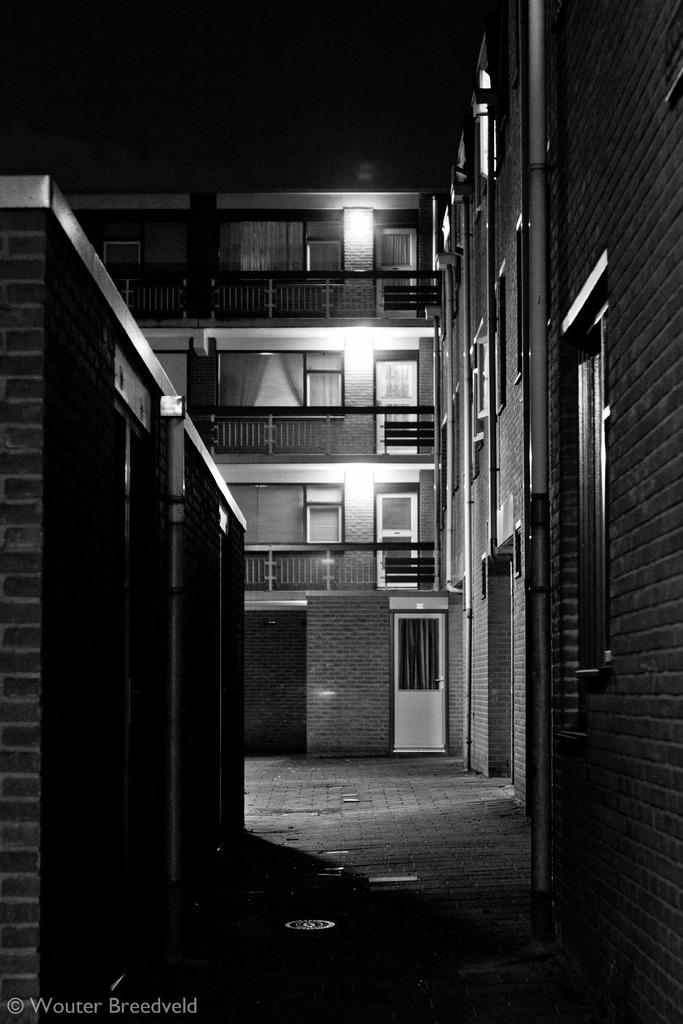What type of structures are visible in the image? There are buildings with lights in the image. What features can be observed on the buildings? The buildings have windows and iron grills. What is visible in the background of the image? There is sky visible in the image. Is there any additional information about the image itself? Yes, there is a watermark on the image. What type of apparel is being worn by the buildings in the image? Buildings do not wear apparel; the question is not applicable to the image. What sound can be heard coming from the buildings in the image? There is no sound present in the image, as it is a still photograph. 